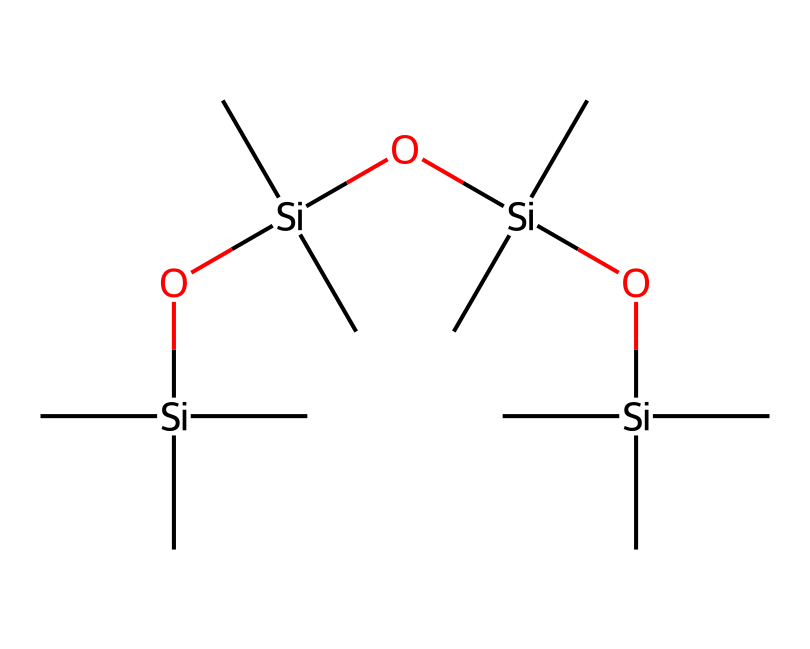What is the total number of silicon atoms in the compound? By analyzing the provided SMILES representation, we can count the occurrences of the silicon atom notation [Si]. The chemical structure shows four occurrences of silicon atoms, indicating a total of four silicon atoms in the compound.
Answer: four How many oxygen atoms are present in the chemical structure? Similar to counting silicon atoms, we check for the oxygen atom notation (O) in the SMILES representation. The structure contains three instances of the oxygen atom, leading to a total of three oxygen atoms in the compound.
Answer: three What type of polymer is indicated by this chemical structure? The SMILES representation shows a repeated siloxane unit (Si-O), which is characteristic of siloxane polymers. This indicates that the compound is a siloxane polymer, specifically used for thermal insulation applications.
Answer: siloxane polymer How many carbon atoms are present in the compound? The presence of carbon atoms can be identified by looking for the notations (C) in the SMILES structure. Each silicon atom is bonded to three carbon atoms, and upon counting, there are twelve carbon atoms represented in this compound.
Answer: twelve What is the primary functional group present in this compound? In the provided chemical structure, the dominant feature is the Si-O linkages, which define it as containing siloxane functional groups. Thus, the primary functional group in this compound can be identified as siloxane.
Answer: siloxane Which characteristic of this molecule contributes to its thermal insulation properties? The presence of long siloxane chains composed of silicon and oxygen contributes to low thermal conductivity, which is essential for its application in thermal insulation materials for ice rinks. This characteristic makes it efficient in minimizing heat transfer.
Answer: low thermal conductivity 